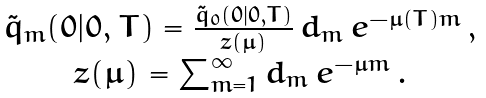<formula> <loc_0><loc_0><loc_500><loc_500>\begin{array} { c } { \tilde { q } } _ { m } ( 0 | 0 , T ) = \frac { { \tilde { q } } _ { 0 } ( 0 | 0 , T ) } { z ( \mu ) } \, d _ { m } \, e ^ { - \mu ( T ) m } \, , \\ z ( \mu ) = \sum _ { m = 1 } ^ { \infty } d _ { m } \, e ^ { - \mu m } \, . \end{array}</formula> 